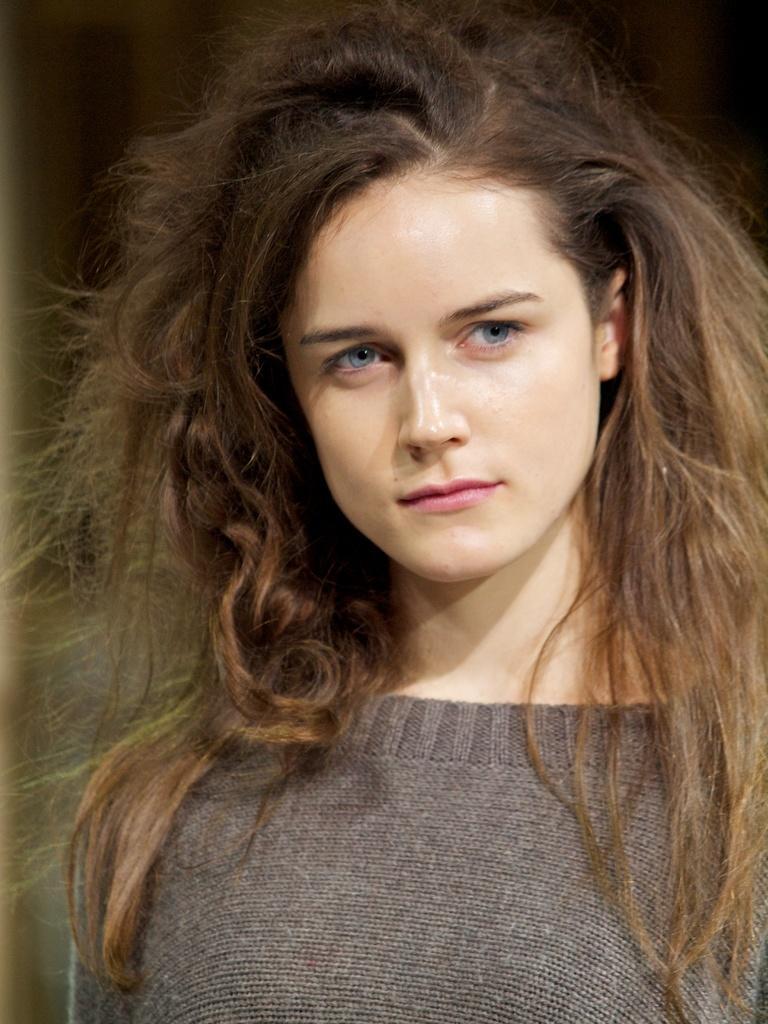In one or two sentences, can you explain what this image depicts? In this image I can see a woman wearing a t-shirt and looking at the right side. The background is blurred. 